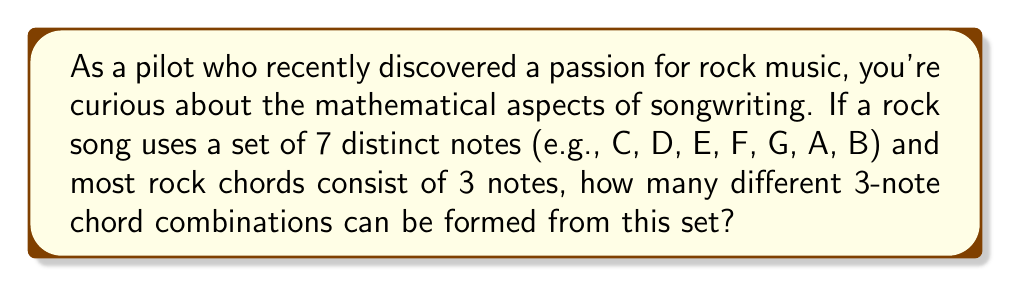Can you solve this math problem? Let's approach this step-by-step:

1) This is a combination problem. We're selecting 3 notes from a set of 7 notes, where the order doesn't matter (since the notes in a chord can be played in any order).

2) The formula for combinations is:

   $$C(n,r) = \frac{n!}{r!(n-r)!}$$

   Where $n$ is the total number of items to choose from, and $r$ is the number of items being chosen.

3) In this case, $n = 7$ (total notes) and $r = 3$ (notes in each chord).

4) Let's substitute these values into our formula:

   $$C(7,3) = \frac{7!}{3!(7-3)!} = \frac{7!}{3!4!}$$

5) Expand this:
   $$\frac{7 \cdot 6 \cdot 5 \cdot 4!}{(3 \cdot 2 \cdot 1) \cdot 4!}$$

6) The $4!$ cancels out in the numerator and denominator:

   $$\frac{7 \cdot 6 \cdot 5}{3 \cdot 2 \cdot 1} = \frac{210}{6}$$

7) Simplify:
   $$210 \div 6 = 35$$

Therefore, there are 35 possible 3-note chord combinations that can be formed from a set of 7 notes.
Answer: 35 